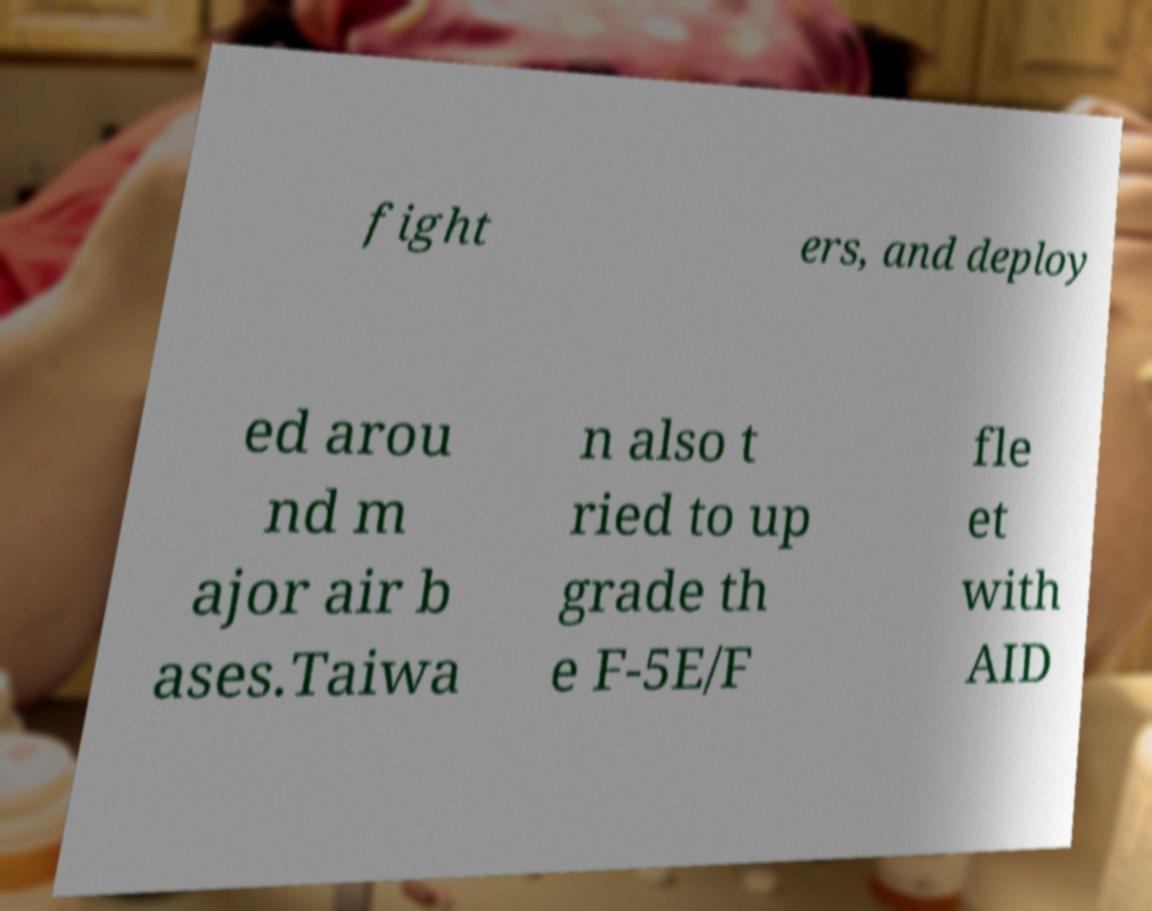There's text embedded in this image that I need extracted. Can you transcribe it verbatim? fight ers, and deploy ed arou nd m ajor air b ases.Taiwa n also t ried to up grade th e F-5E/F fle et with AID 